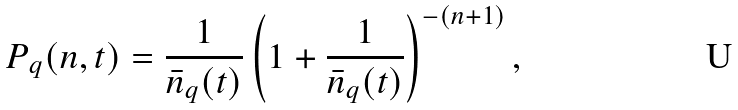Convert formula to latex. <formula><loc_0><loc_0><loc_500><loc_500>P _ { q } ( n , t ) = \frac { 1 } { \bar { n } _ { q } ( t ) } \left ( 1 + \frac { 1 } { \bar { n } _ { q } ( t ) } \right ) ^ { - ( n + 1 ) } ,</formula> 